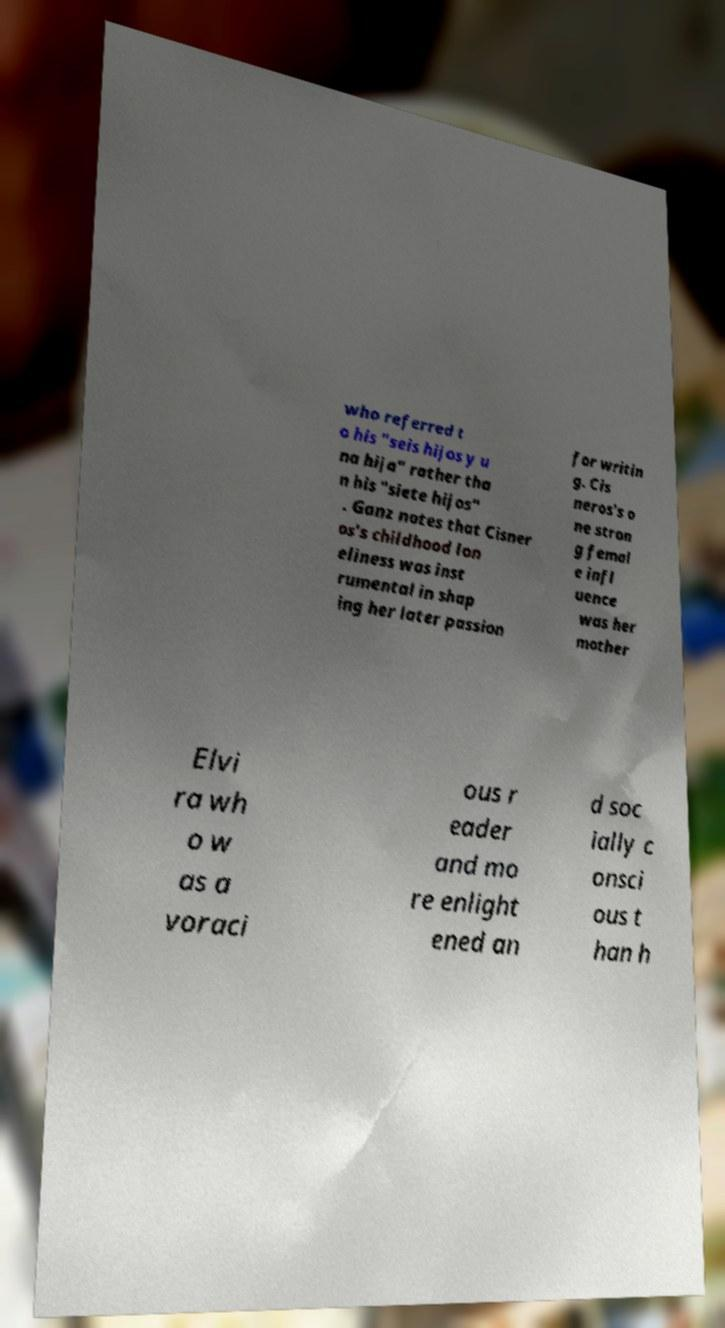There's text embedded in this image that I need extracted. Can you transcribe it verbatim? who referred t o his "seis hijos y u na hija" rather tha n his "siete hijos" . Ganz notes that Cisner os's childhood lon eliness was inst rumental in shap ing her later passion for writin g. Cis neros's o ne stron g femal e infl uence was her mother Elvi ra wh o w as a voraci ous r eader and mo re enlight ened an d soc ially c onsci ous t han h 